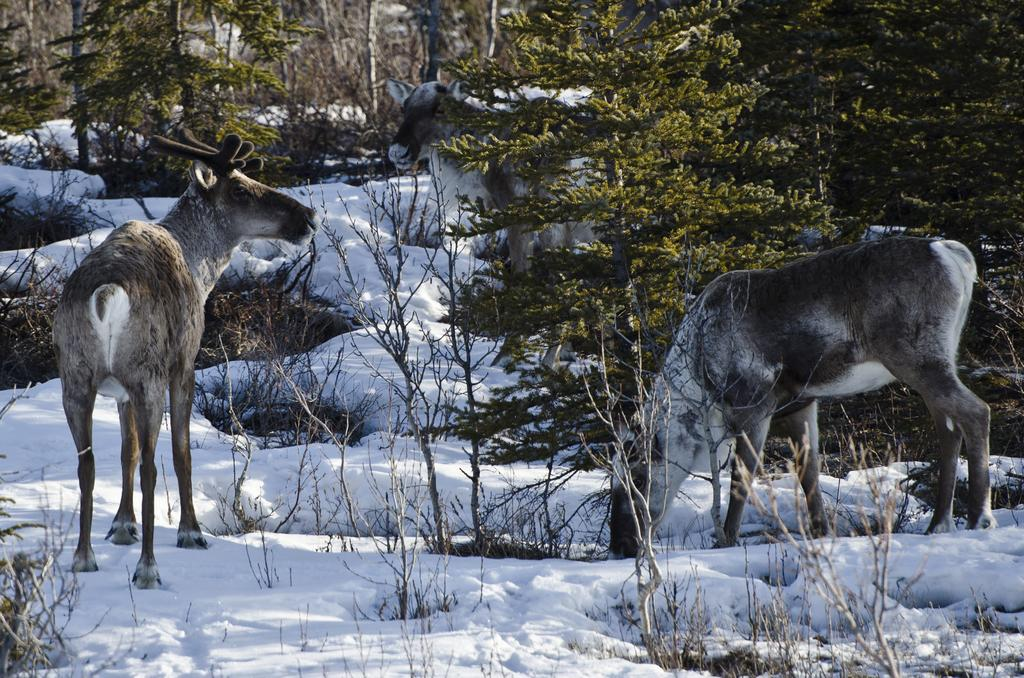What type of animals can be seen on the ground in the image? There are animals on the ground in the image. What is the weather like in the image? There is snow visible in the image, indicating a snowy environment. What type of vegetation is present in the image? There are plants in the image. What can be seen in the background of the image? There is a group of trees in the image. How many geese are sitting in the crib in the image? There is no crib or geese present in the image. What type of precipitation is falling from the sky in the image? The image does not show any precipitation falling from the sky; it only shows snow on the ground. 